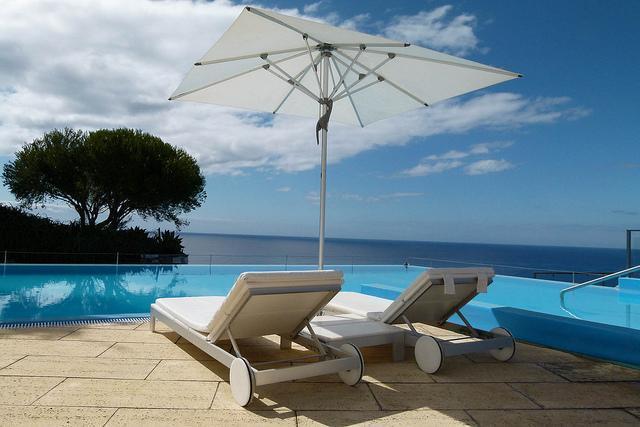What would a person be doing here?
Select the accurate response from the four choices given to answer the question.
Options: Flying, digging, burying, relaxing. Relaxing. 